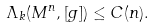<formula> <loc_0><loc_0><loc_500><loc_500>\Lambda _ { k } ( M ^ { n } , [ g ] ) \leq C ( n ) .</formula> 